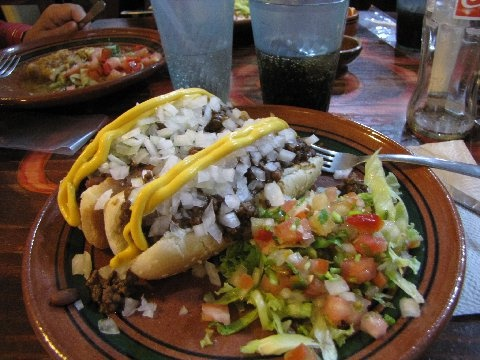Describe the objects in this image and their specific colors. I can see hot dog in black, darkgray, gray, and tan tones, dining table in black, maroon, and gray tones, cup in black, gray, and blue tones, bottle in black, gray, and maroon tones, and cup in black, gray, and blue tones in this image. 